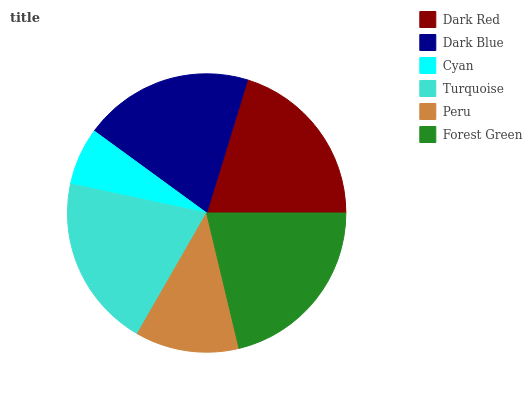Is Cyan the minimum?
Answer yes or no. Yes. Is Forest Green the maximum?
Answer yes or no. Yes. Is Dark Blue the minimum?
Answer yes or no. No. Is Dark Blue the maximum?
Answer yes or no. No. Is Dark Red greater than Dark Blue?
Answer yes or no. Yes. Is Dark Blue less than Dark Red?
Answer yes or no. Yes. Is Dark Blue greater than Dark Red?
Answer yes or no. No. Is Dark Red less than Dark Blue?
Answer yes or no. No. Is Turquoise the high median?
Answer yes or no. Yes. Is Dark Blue the low median?
Answer yes or no. Yes. Is Dark Red the high median?
Answer yes or no. No. Is Peru the low median?
Answer yes or no. No. 